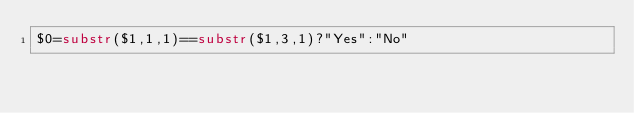Convert code to text. <code><loc_0><loc_0><loc_500><loc_500><_Awk_>$0=substr($1,1,1)==substr($1,3,1)?"Yes":"No"</code> 